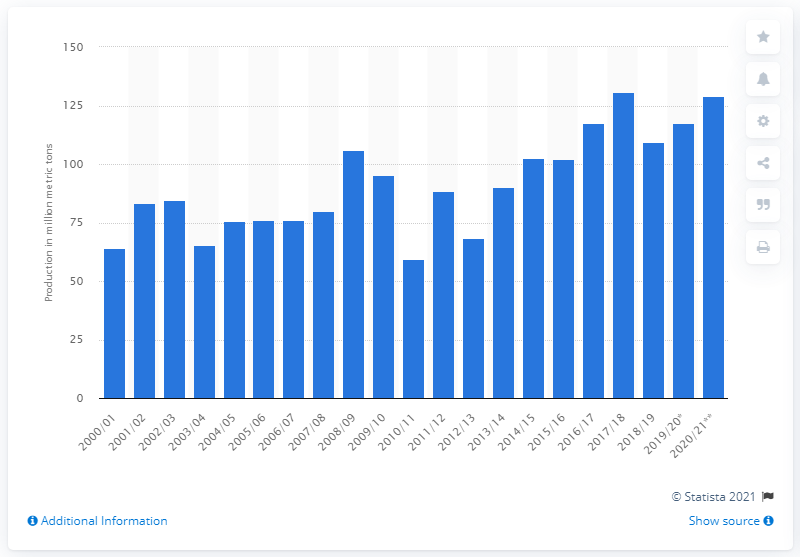Highlight a few significant elements in this photo. According to the forecast, Russia's cereal production for the 2020/2021 season is expected to be 129.2 million metric tons. 